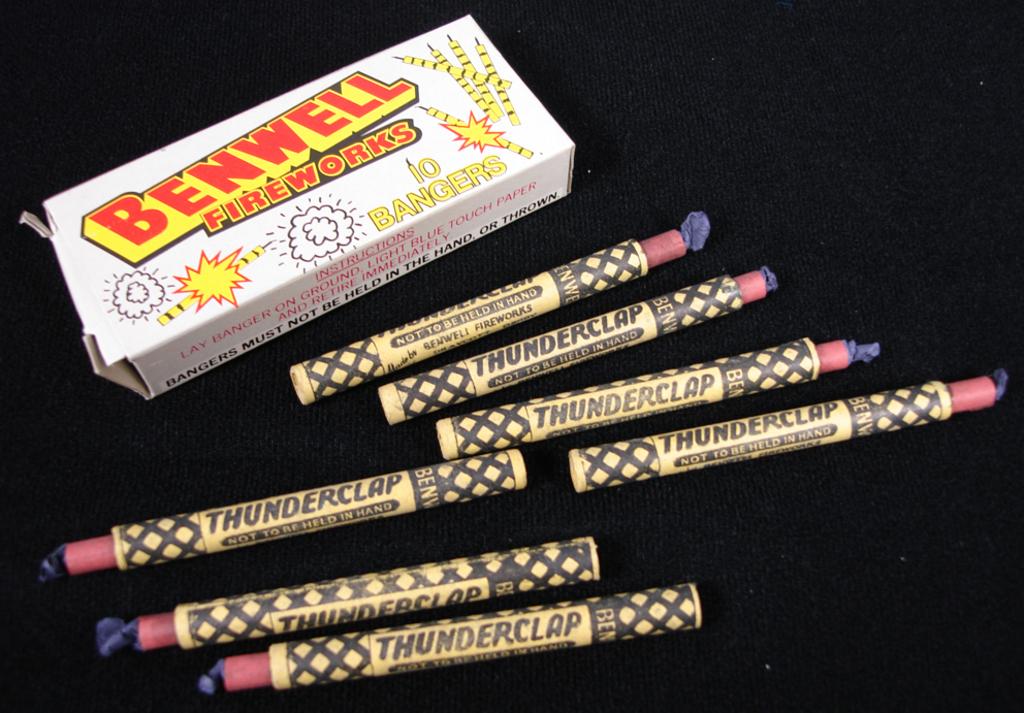What company is this made by?
Make the answer very short. Benwell. What is the name of the fireworks?
Keep it short and to the point. Benwell. 